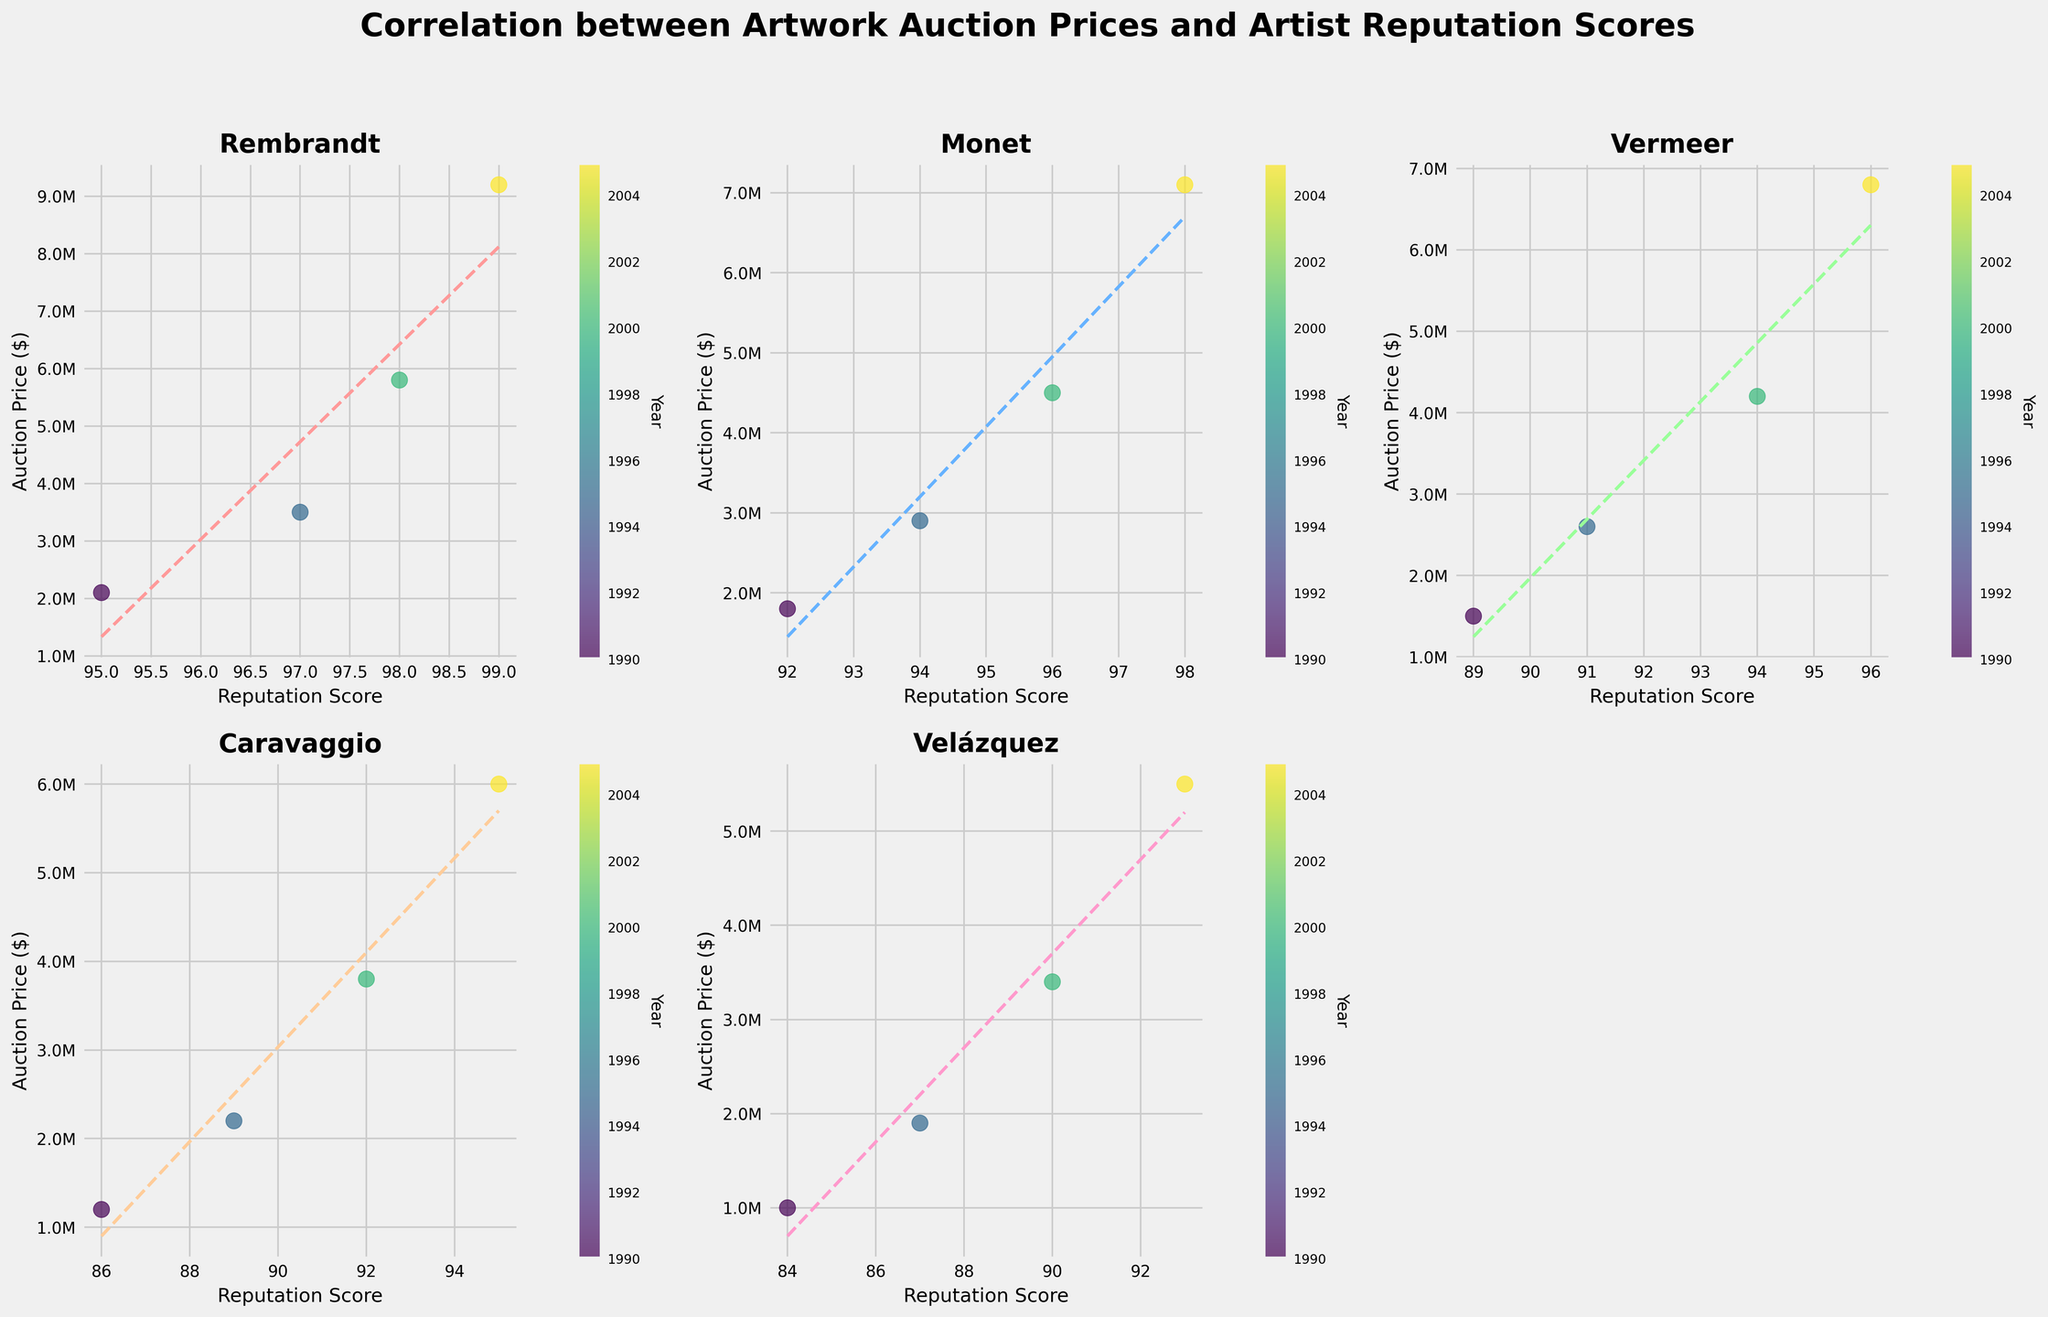What is the title of the figure? The title is usually placed at the top of the figure. The title in this case is located above all the subplots.
Answer: "Correlation between Artwork Auction Prices and Artist Reputation Scores" Which artist's plot is missing and why might that be? In a rectangular grid layout of 2 rows and 3 columns for organizing the plots, if there are only five artists, one subplot will be empty because 5 is not enough to fill all six slots. The figure appears to use color and empty space logically.
Answer: Velázquez's plot is missing Which artist shows the highest auction price in 2005? By examining the scatter points for all subplots, Rembrandt's data points show the highest auction price in 2005.
Answer: Rembrandt How does auction price correlate with reputation for Monet's artworks? Look at the subplot for Monet. The upward slope trendline indicates a positive correlation; as the reputation score increases, so does the auction price.
Answer: Positive correlation Which artist has the lowest reputation score in 1990? Identify 1990 points in each scatter plot by the color representing the earliest year, then check reputation scores. Velázquez has the lowest score in 1990.
Answer: Velázquez Who had a faster increase in auction price from 1990 to 2005, Caravaggio or Vermeer? Subtract the 1990 auction price from the 2005 auction price for both artists (6000000 - 1200000 for Caravaggio and 6800000 - 1500000 for Vermeer). Vermeer has a higher difference.
Answer: Vermeer What is the general trend in auction prices over time for all artists? Observe the scatter plots' color-coding by year. The points are generally moving up indicating an overall increasing trend in auction prices over time for all artists.
Answer: Increasing trend Between Rembrandt and Monet, who has more scatter points in the plot? Each subplot is dedicated to one artist, making it easy to count the dots directly. Both have an equal number of points when comparing the years provided (4 points each).
Answer: Rembrandt and Monet have equal points How does the correlation trendline for Caravaggio compare to other artists? Analyze the slopes of the trendlines for each artist. Caravaggio's trendline slope is positive but less steep compared to Rembrandt's and Vermeer's trendlines.
Answer: Less steep positive trendline 